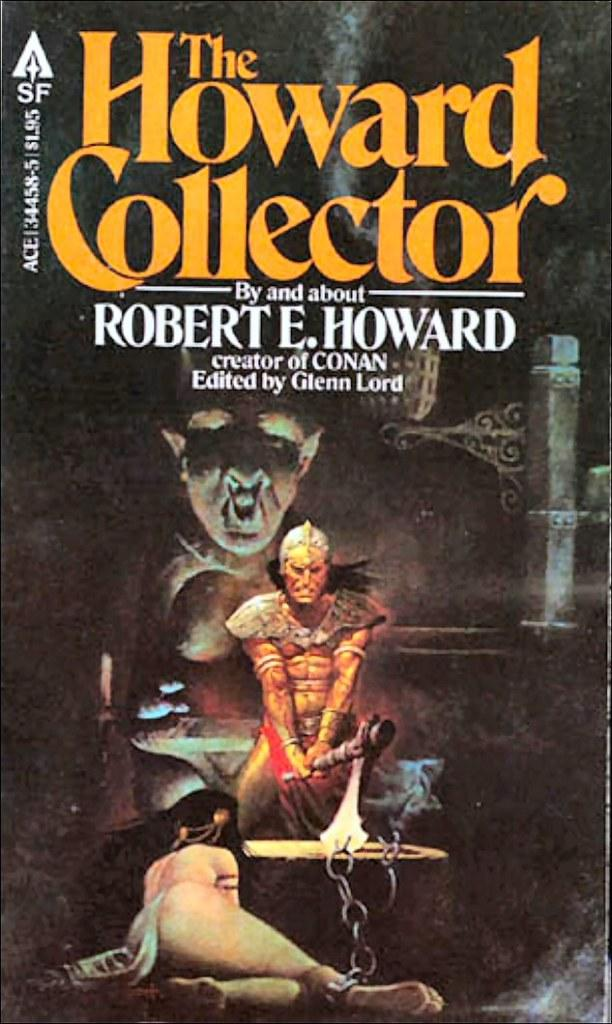What is the main subject of the image? The main subject of the image is a cover page. How many people are depicted on the cover page? There are two persons on the cover page. What else can be seen on the cover page besides the people? There is text on the cover page. How many books are being used in the operation shown on the cover page? There is no operation or books present on the cover page; it only features a cover page with two persons and text. 